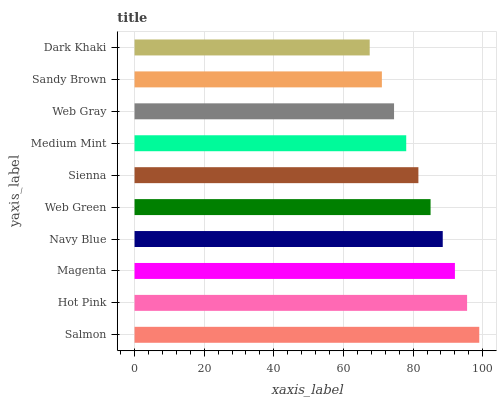Is Dark Khaki the minimum?
Answer yes or no. Yes. Is Salmon the maximum?
Answer yes or no. Yes. Is Hot Pink the minimum?
Answer yes or no. No. Is Hot Pink the maximum?
Answer yes or no. No. Is Salmon greater than Hot Pink?
Answer yes or no. Yes. Is Hot Pink less than Salmon?
Answer yes or no. Yes. Is Hot Pink greater than Salmon?
Answer yes or no. No. Is Salmon less than Hot Pink?
Answer yes or no. No. Is Web Green the high median?
Answer yes or no. Yes. Is Sienna the low median?
Answer yes or no. Yes. Is Hot Pink the high median?
Answer yes or no. No. Is Sandy Brown the low median?
Answer yes or no. No. 